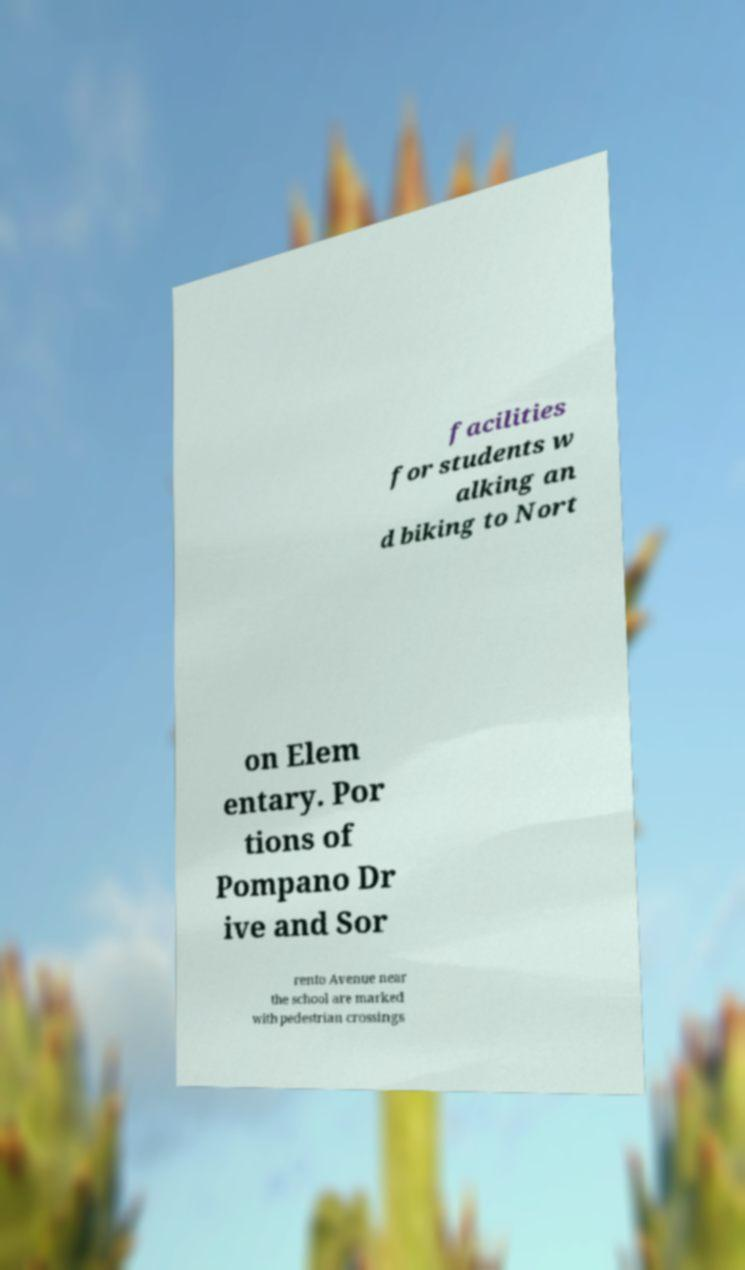For documentation purposes, I need the text within this image transcribed. Could you provide that? facilities for students w alking an d biking to Nort on Elem entary. Por tions of Pompano Dr ive and Sor rento Avenue near the school are marked with pedestrian crossings 